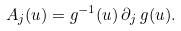Convert formula to latex. <formula><loc_0><loc_0><loc_500><loc_500>A _ { j } ( u ) = g ^ { - 1 } ( u ) \, \partial _ { j } \, g ( u ) .</formula> 